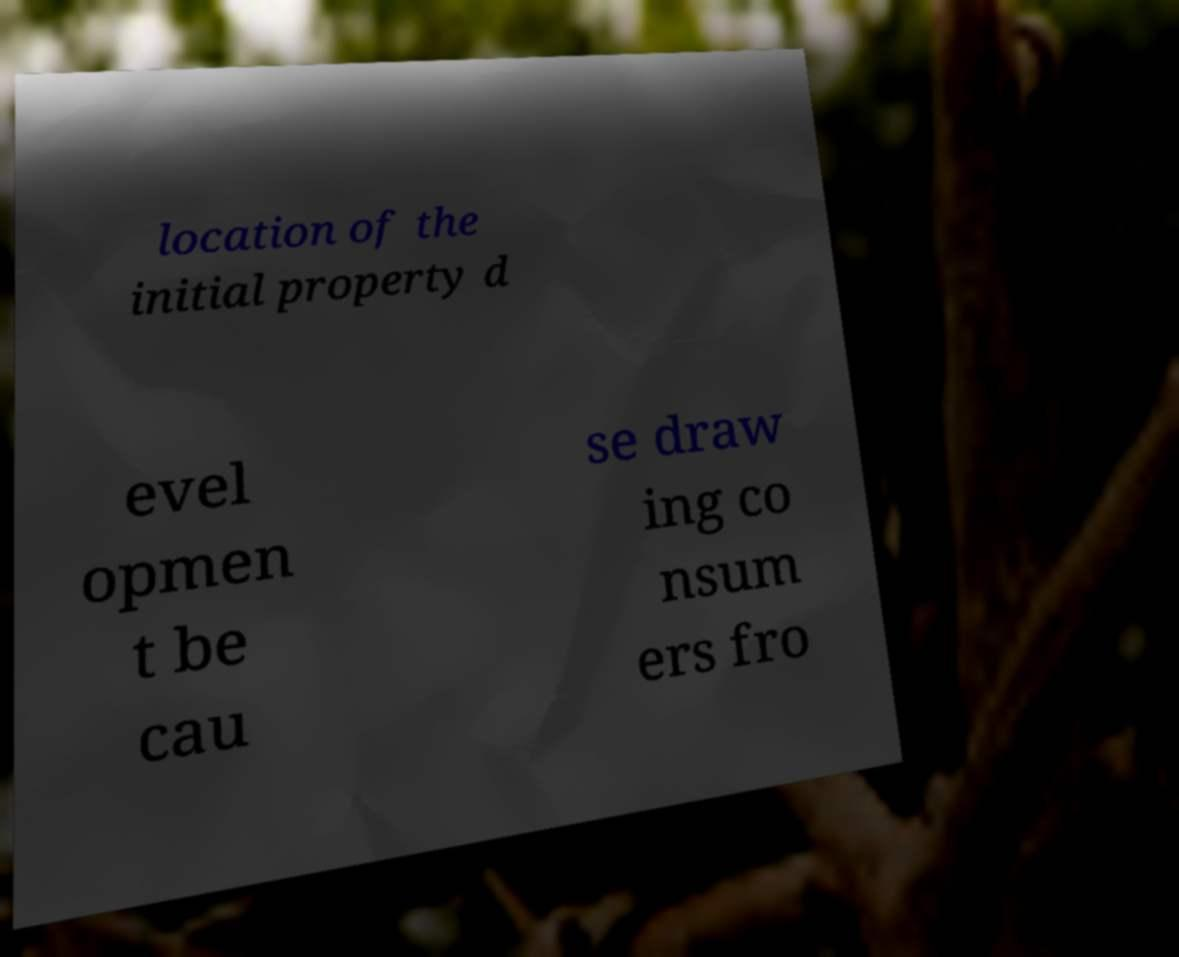Please identify and transcribe the text found in this image. location of the initial property d evel opmen t be cau se draw ing co nsum ers fro 